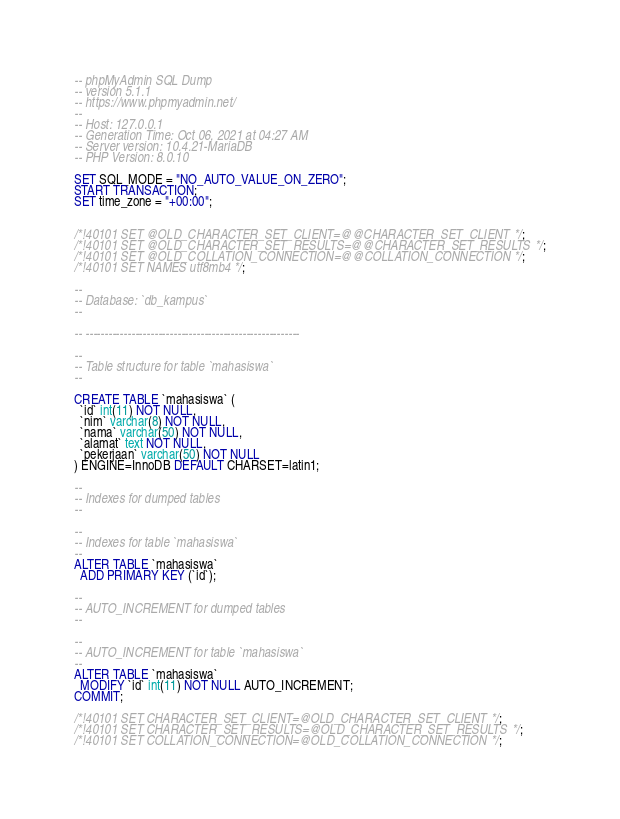Convert code to text. <code><loc_0><loc_0><loc_500><loc_500><_SQL_>-- phpMyAdmin SQL Dump
-- version 5.1.1
-- https://www.phpmyadmin.net/
--
-- Host: 127.0.0.1
-- Generation Time: Oct 06, 2021 at 04:27 AM
-- Server version: 10.4.21-MariaDB
-- PHP Version: 8.0.10

SET SQL_MODE = "NO_AUTO_VALUE_ON_ZERO";
START TRANSACTION;
SET time_zone = "+00:00";


/*!40101 SET @OLD_CHARACTER_SET_CLIENT=@@CHARACTER_SET_CLIENT */;
/*!40101 SET @OLD_CHARACTER_SET_RESULTS=@@CHARACTER_SET_RESULTS */;
/*!40101 SET @OLD_COLLATION_CONNECTION=@@COLLATION_CONNECTION */;
/*!40101 SET NAMES utf8mb4 */;

--
-- Database: `db_kampus`
--

-- --------------------------------------------------------

--
-- Table structure for table `mahasiswa`
--

CREATE TABLE `mahasiswa` (
  `id` int(11) NOT NULL,
  `nim` varchar(8) NOT NULL,
  `nama` varchar(50) NOT NULL,
  `alamat` text NOT NULL,
  `pekerjaan` varchar(50) NOT NULL
) ENGINE=InnoDB DEFAULT CHARSET=latin1;

--
-- Indexes for dumped tables
--

--
-- Indexes for table `mahasiswa`
--
ALTER TABLE `mahasiswa`
  ADD PRIMARY KEY (`id`);

--
-- AUTO_INCREMENT for dumped tables
--

--
-- AUTO_INCREMENT for table `mahasiswa`
--
ALTER TABLE `mahasiswa`
  MODIFY `id` int(11) NOT NULL AUTO_INCREMENT;
COMMIT;

/*!40101 SET CHARACTER_SET_CLIENT=@OLD_CHARACTER_SET_CLIENT */;
/*!40101 SET CHARACTER_SET_RESULTS=@OLD_CHARACTER_SET_RESULTS */;
/*!40101 SET COLLATION_CONNECTION=@OLD_COLLATION_CONNECTION */;
</code> 